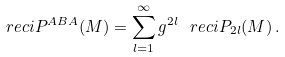<formula> <loc_0><loc_0><loc_500><loc_500>\ r e c i P ^ { A B A } ( M ) = \sum _ { l = 1 } ^ { \infty } g ^ { 2 l } \, \ r e c i P _ { 2 l } ( M ) \, .</formula> 